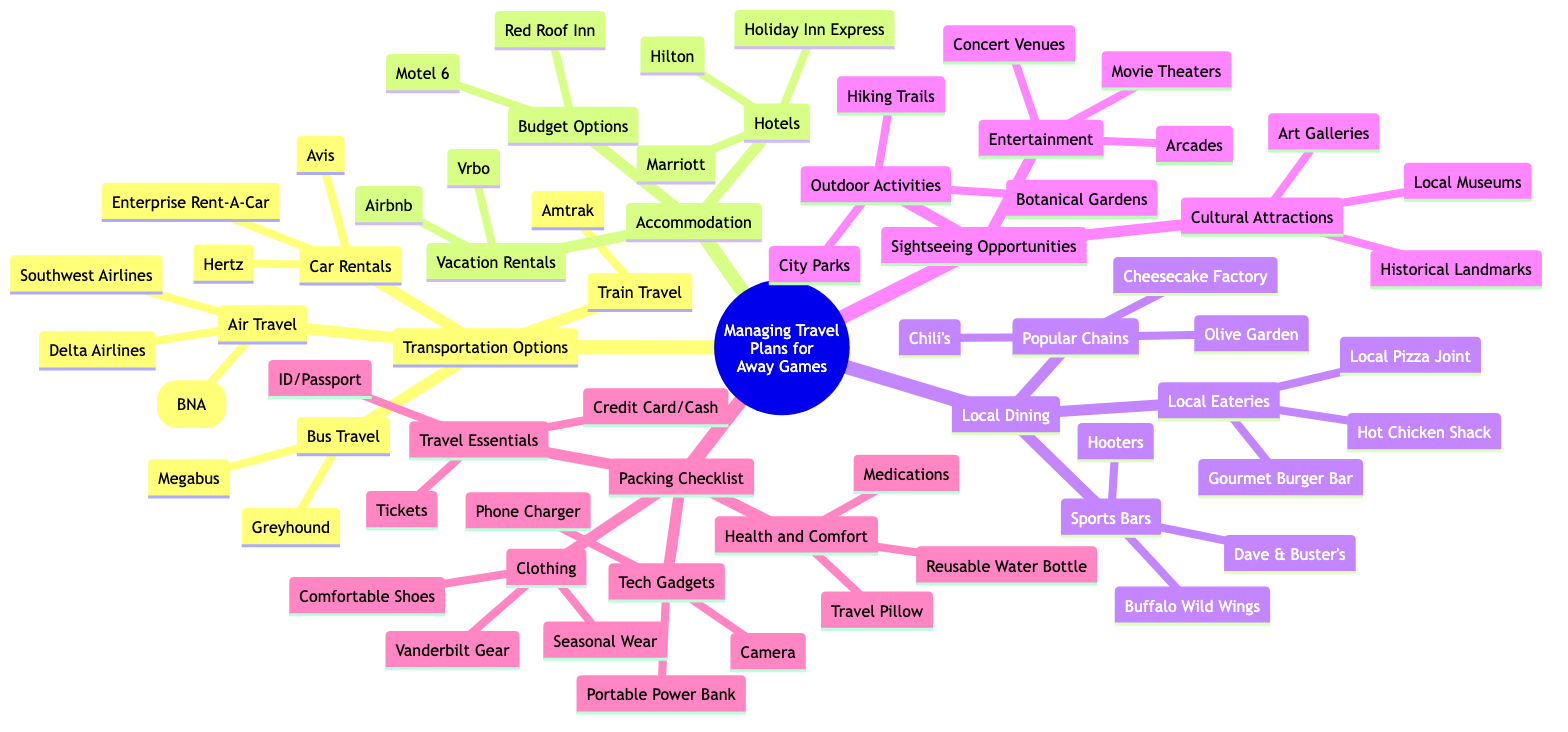What transportation option is available for bus travel? The diagram lists two options under "Bus Travel," which are Greyhound and Megabus. By identifying the correct node and its corresponding sub-nodes, I can see the available options.
Answer: Greyhound, Megabus What kind of accommodation can you find in budget options? Under the "Accommodation" category, there is a node for "Budget Options" that includes Motel 6 and Red Roof Inn. I can find this information by following the category down to its sub-nodes.
Answer: Motel 6, Red Roof Inn How many local eateries are listed? The "Local Eateries" sub-node is part of the "Local Dining" category. The diagram shows three local eatery options: Hot Chicken Shack, Local Pizza Joint, and Gourmet Burger Bar. Counting these options provides the answer.
Answer: 3 What are two types of local dining options? The diagram has two main branches under "Local Dining": "Popular Chains" and "Local Eateries". I can find examples by looking at the items within each sub-node. The question can be answered by listing examples from each.
Answer: Popular Chains, Local Eateries Which packing checklist category includes medications? In the "Packing Checklist" section, there is a sub-node under "Health and Comfort" that specifically lists medications. Following the diagram structure leads directly to this category.
Answer: Health and Comfort What is the primary mode of air travel listed? The "Transportation Options" section provides a sub-node for "Air Travel" that includes Nashville International Airport (BNA), Delta Airlines, and Southwest Airlines. Identifying this primary node gives the answer.
Answer: Nashville International Airport (BNA) List one sightseeing opportunity related to cultural attractions. The diagram references "Sightseeing Opportunities," which has a node dedicated to "Cultural Attractions," including options such as Local Museums, Historical Landmarks, and Art Galleries. By identifying one of these options, I can provide the answer.
Answer: Local Museums What are the types of rental car services listed? Under "Transportation Options" in the "Car Rentals" sub-node, three services are mentioned: Enterprise Rent-A-Car, Hertz, and Avis. Listing these services provides the answer.
Answer: Enterprise Rent-A-Car, Hertz, Avis What is one type of travel essential mentioned? Within the "Packing Checklist," there is a category called "Travel Essentials" that includes items like Tickets, ID/Passport, and Credit Card/Cash. I can select one item from this category to answer the question.
Answer: Tickets 